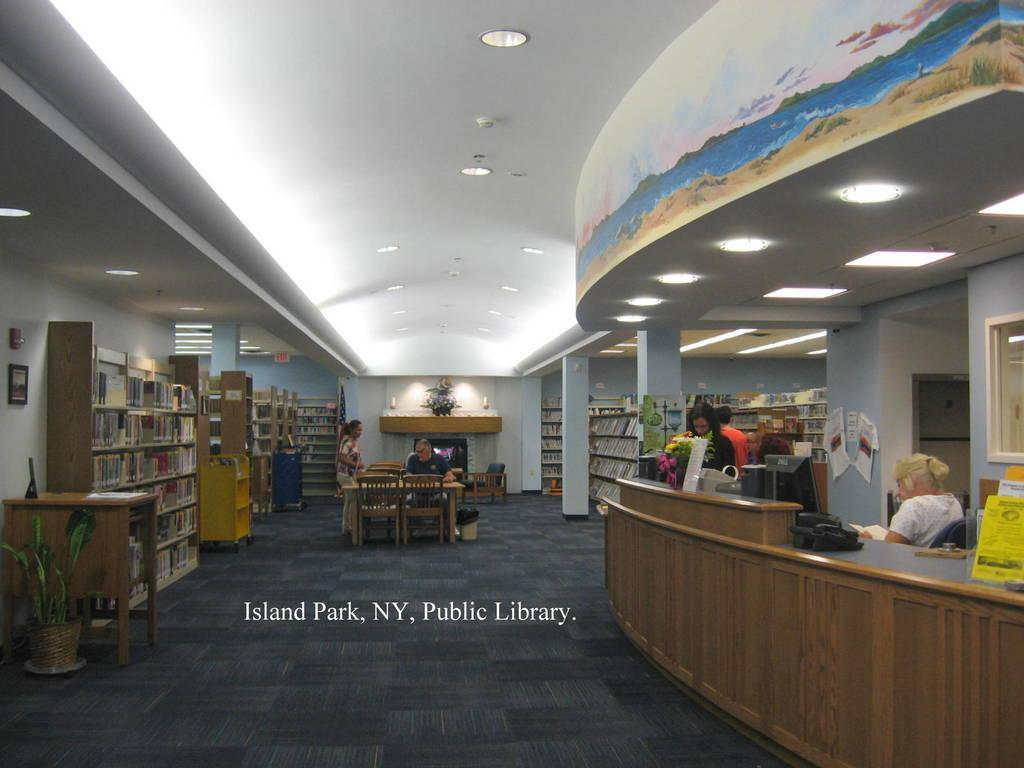Who or what can be seen in the image? There are people in the image. What type of furniture is present in the image? There are chairs and tables in the image. What objects are related to learning or reading in the image? There are books in the image. What type of greenery is present in the image? There are plants in the image. What is hanging on the wall in the image? There is a frame on a wall in the image. What type of plot is being discussed by the people in the image? There is no indication of a plot or conversation being discussed in the image; it only shows people, furniture, books, plants, and a frame on the wall. 